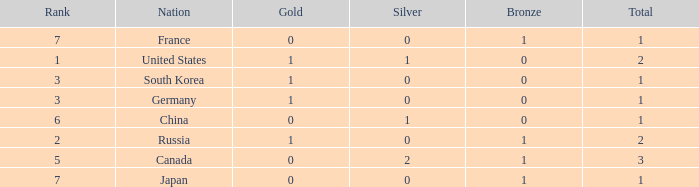Which Rank has a Nation of south korea, and a Silver larger than 0? None. 